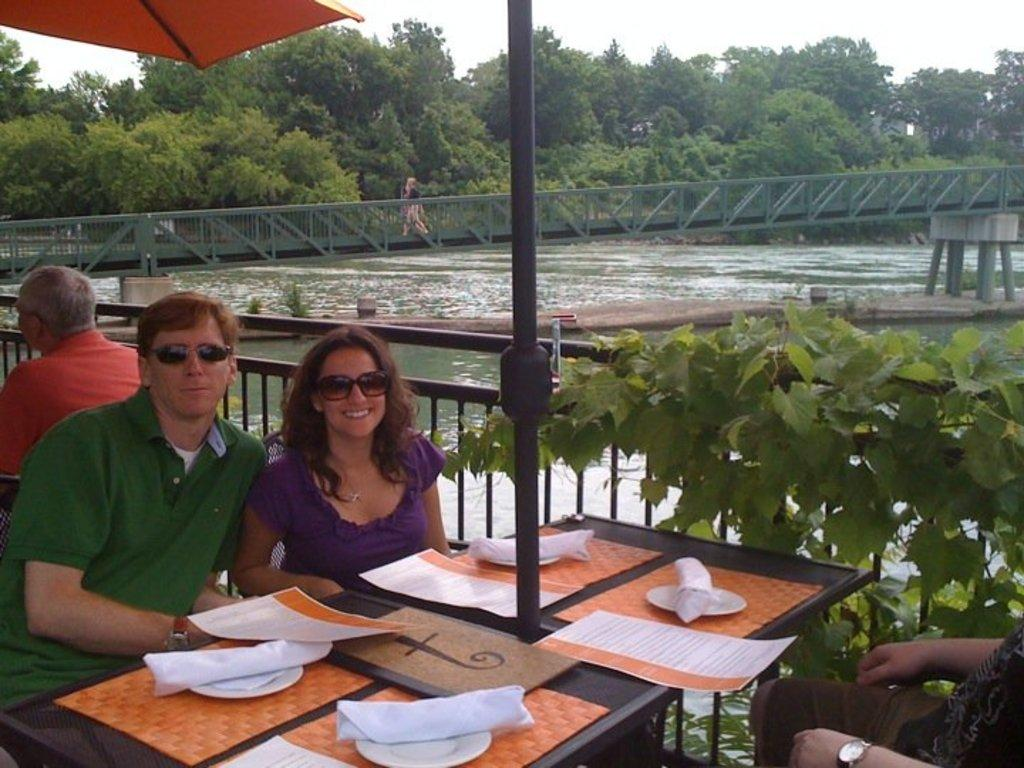What type of natural environment is visible in the image? There are trees in the image, which suggests a natural environment. What can be seen in the sky in the image? The sky is visible in the image. What type of structure is present in the image? There is a bridge in the image. What is the body of water in the image used for? The presence of water in the image suggests it might be a river or lake. What are the people in the image doing? There are people sitting on chairs in the image, which suggests they might be resting or having a meal. What is on the table in the image? There are papers and plates on the table in the image. Can you tell me how many dinosaurs are swimming in the water in the image? There are no dinosaurs present in the image; it features a natural environment with a bridge, trees, and water. What type of need is being used by the people in the image? There is no mention of a need in the image; the people are sitting on chairs and there are papers and plates on the table. 